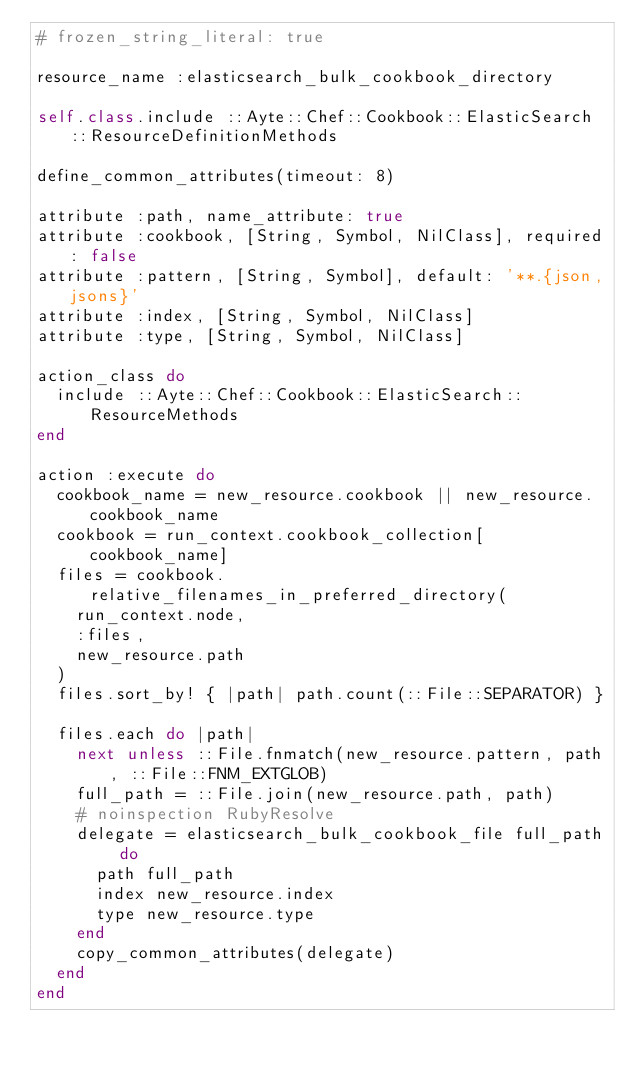Convert code to text. <code><loc_0><loc_0><loc_500><loc_500><_Ruby_># frozen_string_literal: true

resource_name :elasticsearch_bulk_cookbook_directory

self.class.include ::Ayte::Chef::Cookbook::ElasticSearch::ResourceDefinitionMethods

define_common_attributes(timeout: 8)

attribute :path, name_attribute: true
attribute :cookbook, [String, Symbol, NilClass], required: false
attribute :pattern, [String, Symbol], default: '**.{json,jsons}'
attribute :index, [String, Symbol, NilClass]
attribute :type, [String, Symbol, NilClass]

action_class do
  include ::Ayte::Chef::Cookbook::ElasticSearch::ResourceMethods
end

action :execute do
  cookbook_name = new_resource.cookbook || new_resource.cookbook_name
  cookbook = run_context.cookbook_collection[cookbook_name]
  files = cookbook.relative_filenames_in_preferred_directory(
    run_context.node,
    :files,
    new_resource.path
  )
  files.sort_by! { |path| path.count(::File::SEPARATOR) }

  files.each do |path|
    next unless ::File.fnmatch(new_resource.pattern, path, ::File::FNM_EXTGLOB)
    full_path = ::File.join(new_resource.path, path)
    # noinspection RubyResolve
    delegate = elasticsearch_bulk_cookbook_file full_path do
      path full_path
      index new_resource.index
      type new_resource.type
    end
    copy_common_attributes(delegate)
  end
end
</code> 